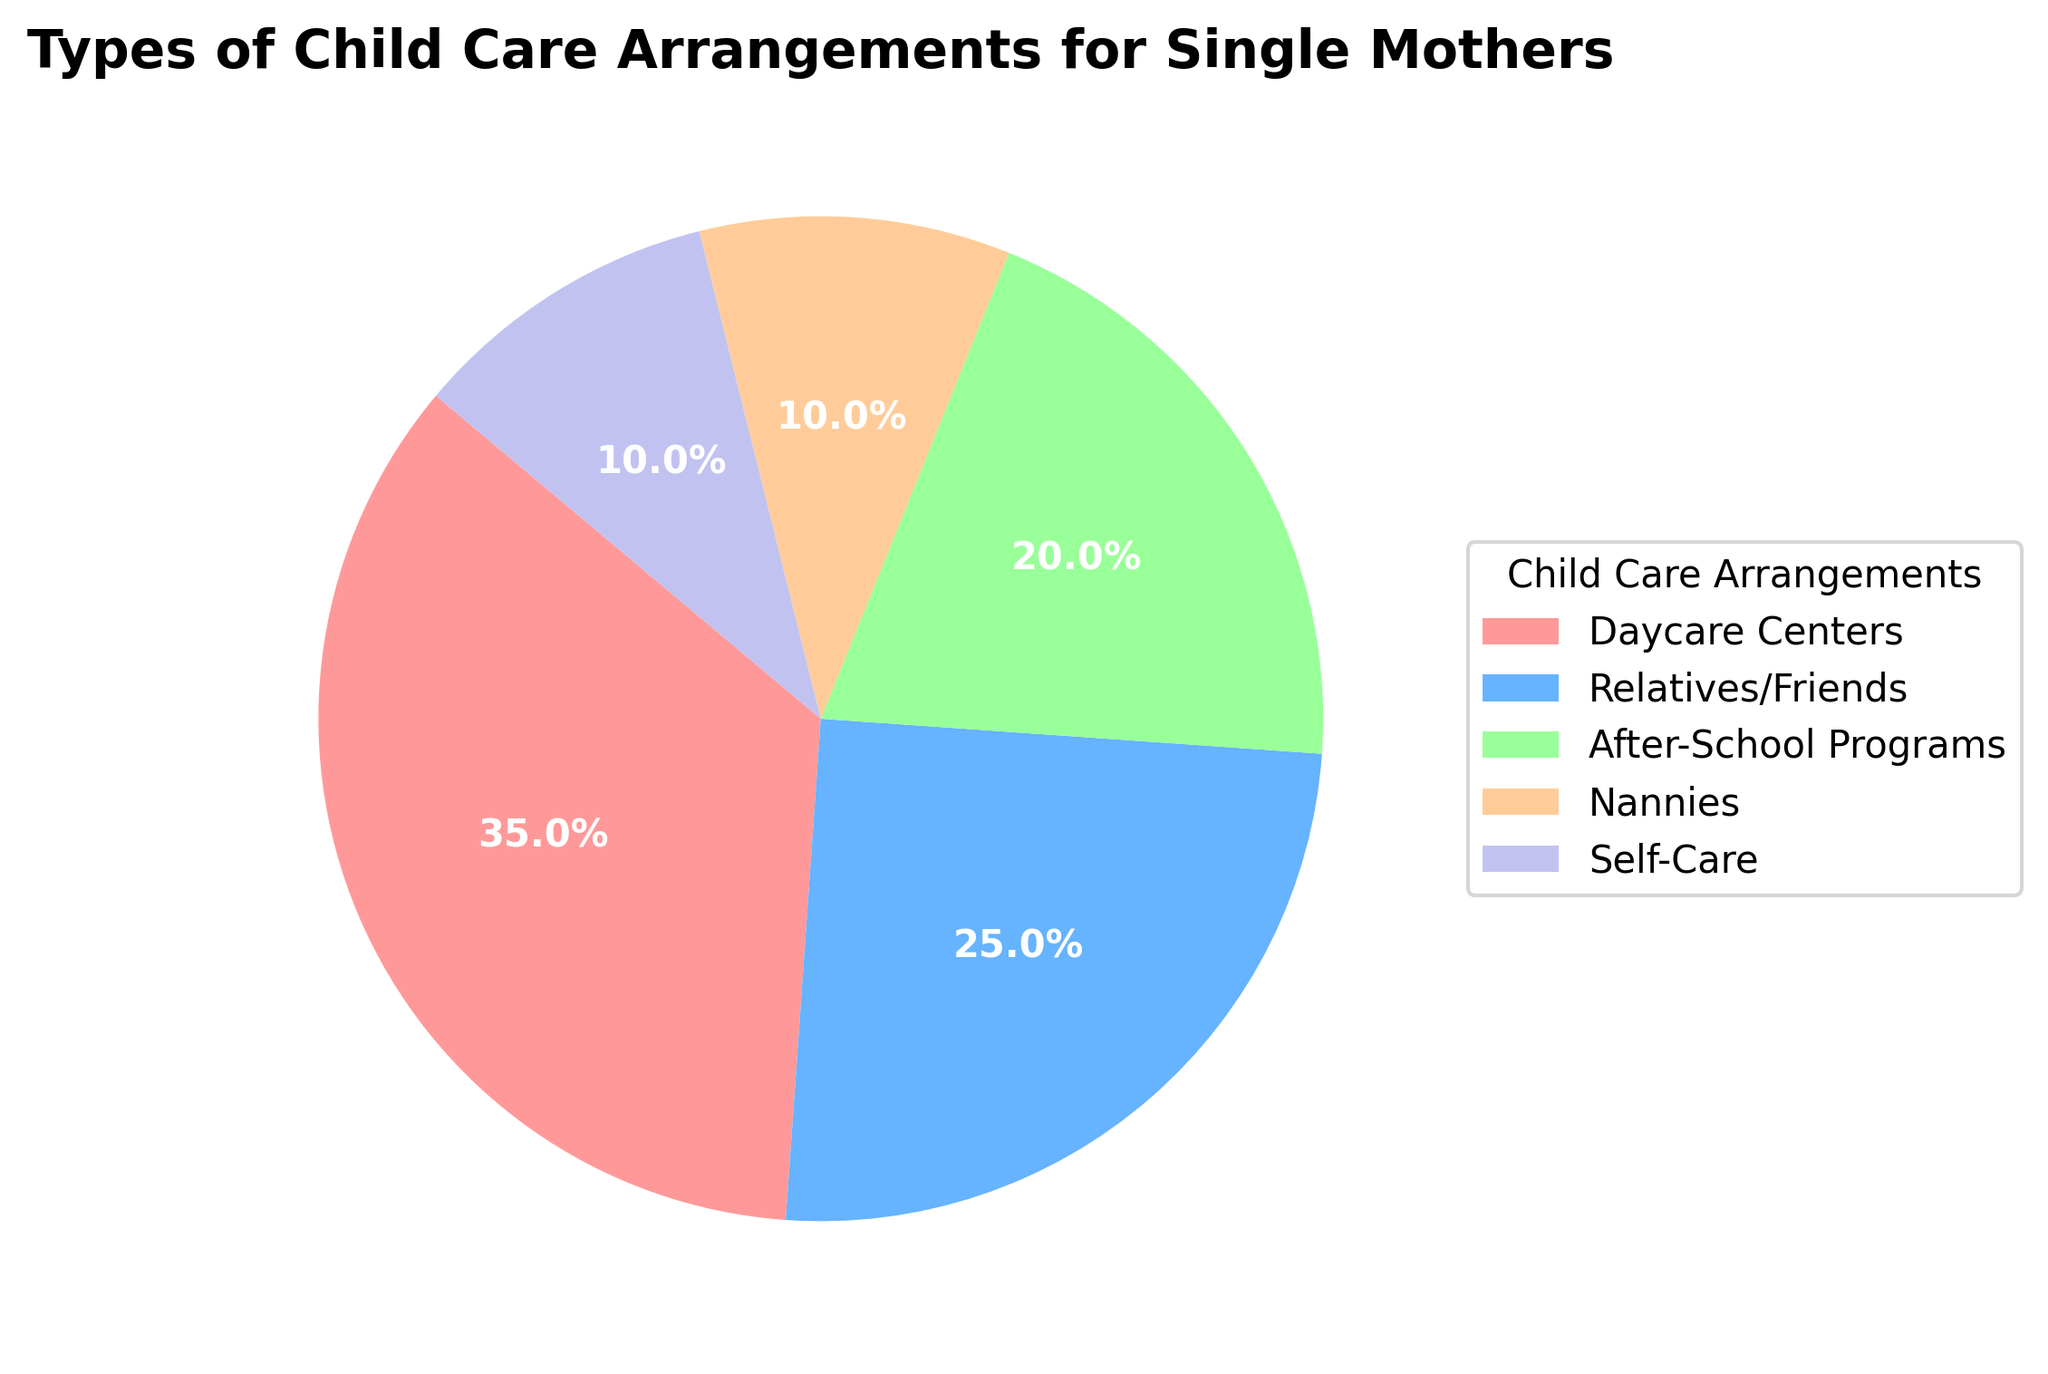What percentage of single mothers use nannies or self-care combined? Adding the percentages for nannies (10%) and self-care (10%), we get 10% + 10% = 20%.
Answer: 20% Which child care arrangement has the highest percentage? By looking at the pie chart, the daycare centers segment is the largest, indicating it has the highest percentage with 35%.
Answer: Daycare Centers How does the percentage of relatives/friends compare to after-school programs? The percentage for relatives/friends (25%) is higher than that for after-school programs (20%).
Answer: Relatives/Friends is higher Which segments are represented in green and blue, respectively? Observing the colors, the green segment represents nannies, and the blue segment represents relatives/friends.
Answer: Nannies and Relatives/Friends What is the total percentage of arrangements that are not daycare centers or relatives/friends? Subtracting the percentages of daycare centers (35%) and relatives/friends (25%) from the total (100%), we get 100% - 35% - 25% = 40%.
Answer: 40% How many types of child care arrangements are there in the pie chart? Counting the different segments, we see that there are five types of child care arrangements.
Answer: 5 Is the percentage of daycare centers more than double that of nannies? The percentage for daycare centers (35%) is indeed more than double that of nannies (10%).
Answer: Yes What portion of the pie chart is taken up by after-school programs and nannies combined? Adding the percentages for after-school programs (20%) and nannies (10%), we get 20% + 10% = 30%.
Answer: 30% What color represents the largest segment in the pie chart? By observing the colors, the red segment represents the largest section, which is daycare centers.
Answer: Red Which child care arrangement has the smallest segment in the pie chart? By looking at the pie chart, both nannies and self-care have the smallest equal segments, each with 10%.
Answer: Nannies and Self-Care 